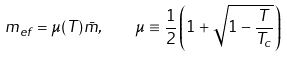<formula> <loc_0><loc_0><loc_500><loc_500>m _ { e f } = \mu ( T ) { \bar { m } } , \quad \mu \equiv \frac { 1 } { 2 } \left ( 1 + \sqrt { 1 - \frac { T } { T _ { c } } } \right )</formula> 